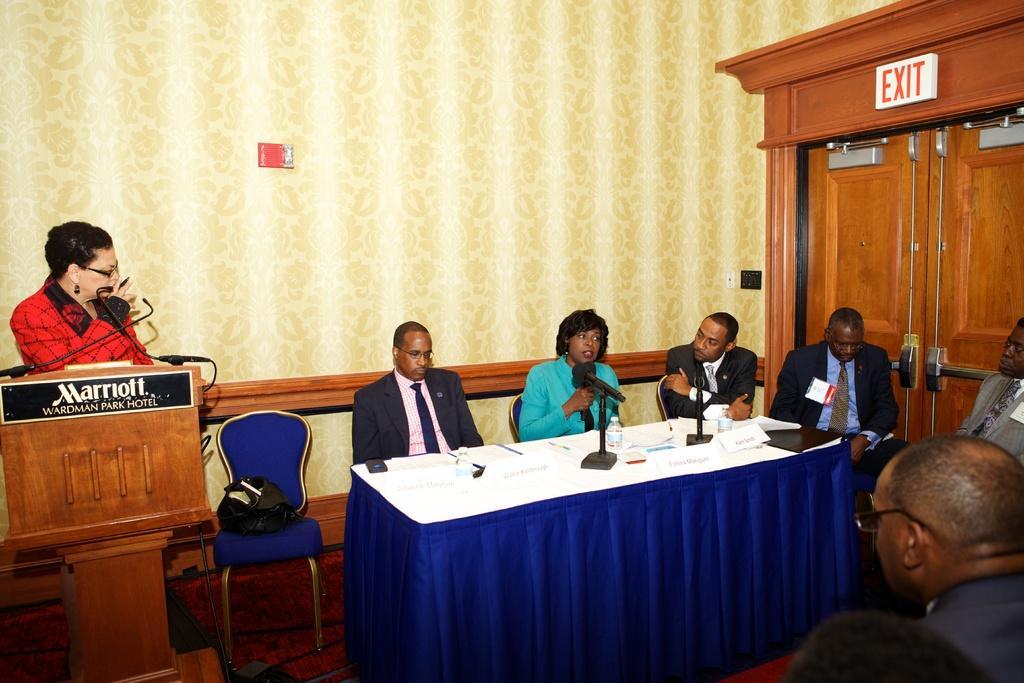Could you give a brief overview of what you see in this image? As we can see in the image there are tiles, few people sitting on chairs and a table. On table there are mice and papers. 